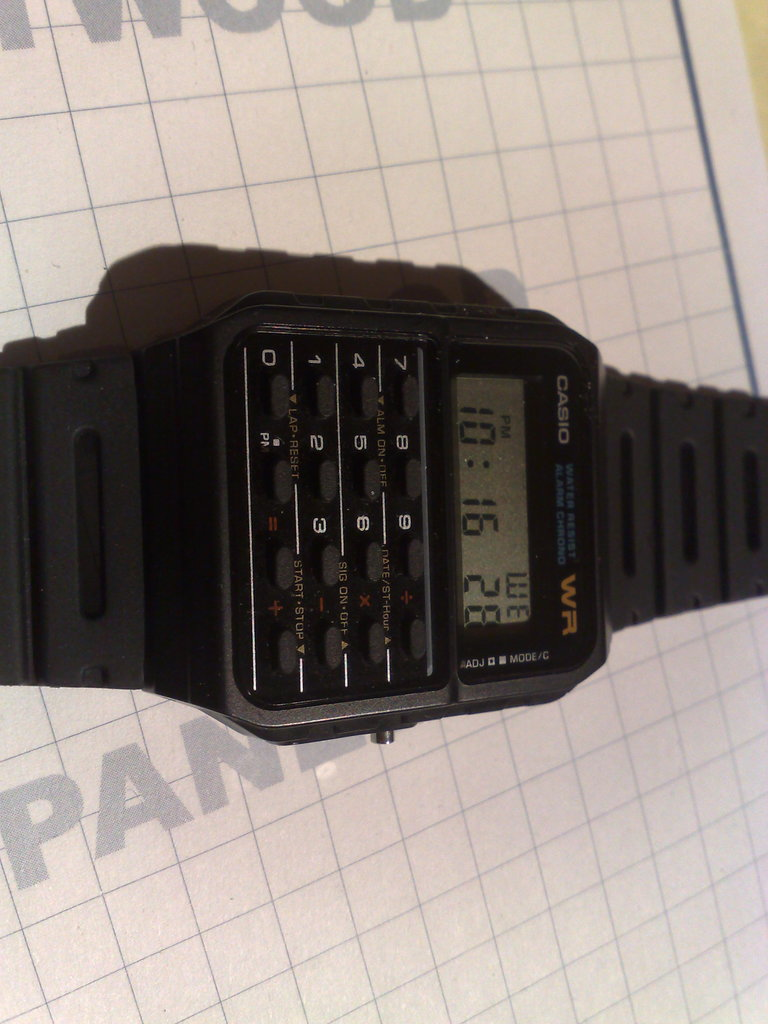Provide a one-sentence caption for the provided image.
Reference OCR token: 0, CASIO, I, UE, ERm, MODE/C An older CASIO brand watch with a calculator on it. 